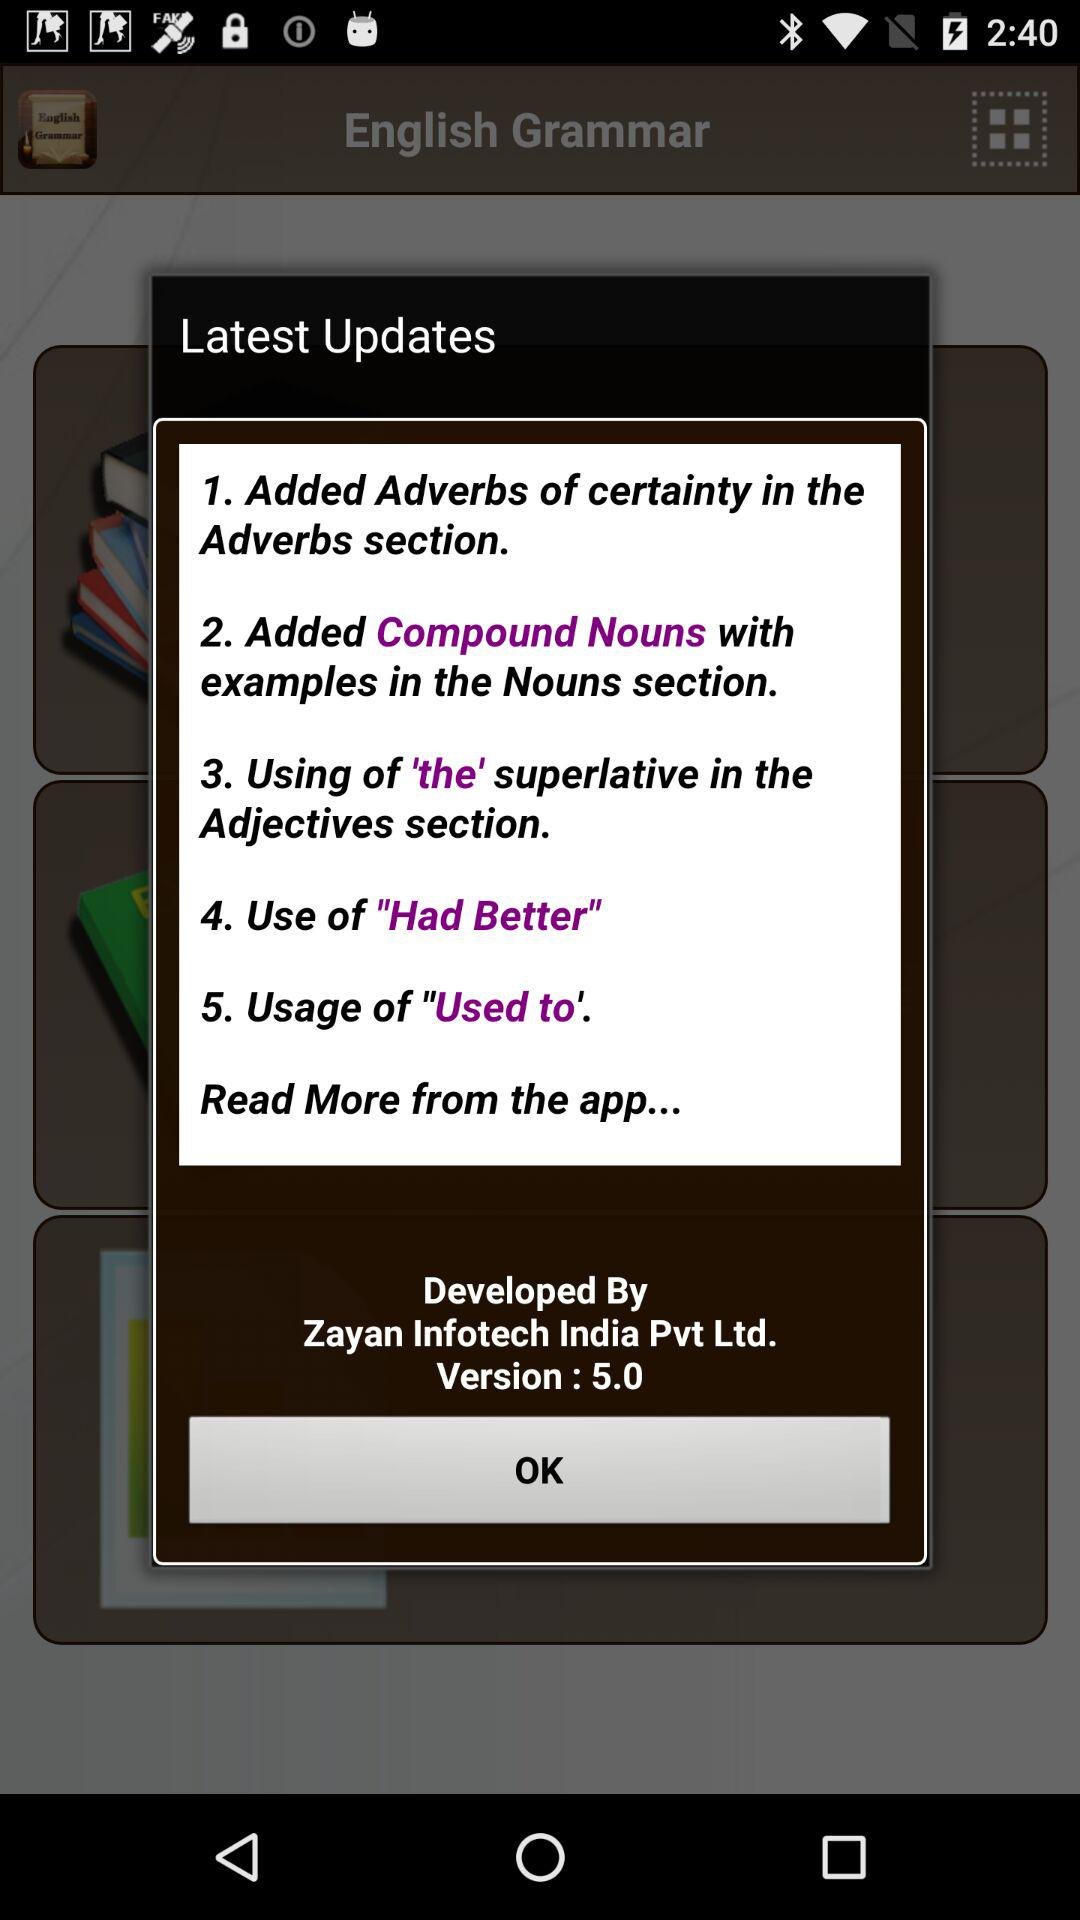When was the latest update made?
When the provided information is insufficient, respond with <no answer>. <no answer> 